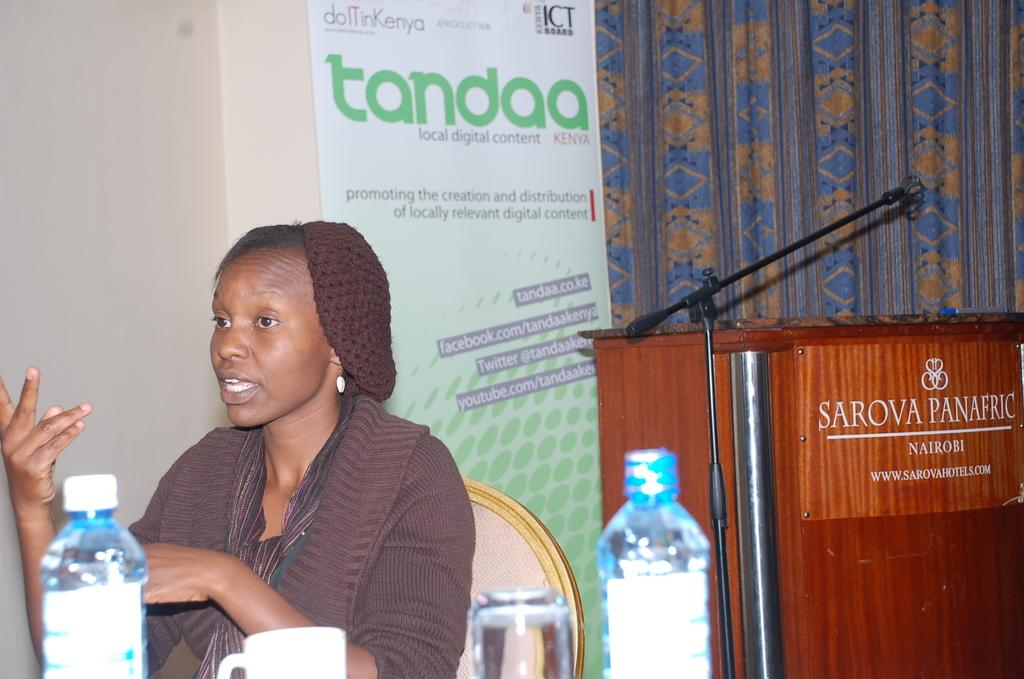What is the main subject of the image? There is a person in the image. What is the person doing in the image? The person is sitting on a chair. What objects are present on the table in the image? There is a water bottle, a glass, and a cup on the table. What type of metal can be seen in the image? There is no metal present in the image. How many potatoes are visible on the table in the image? There are no potatoes present in the image. 